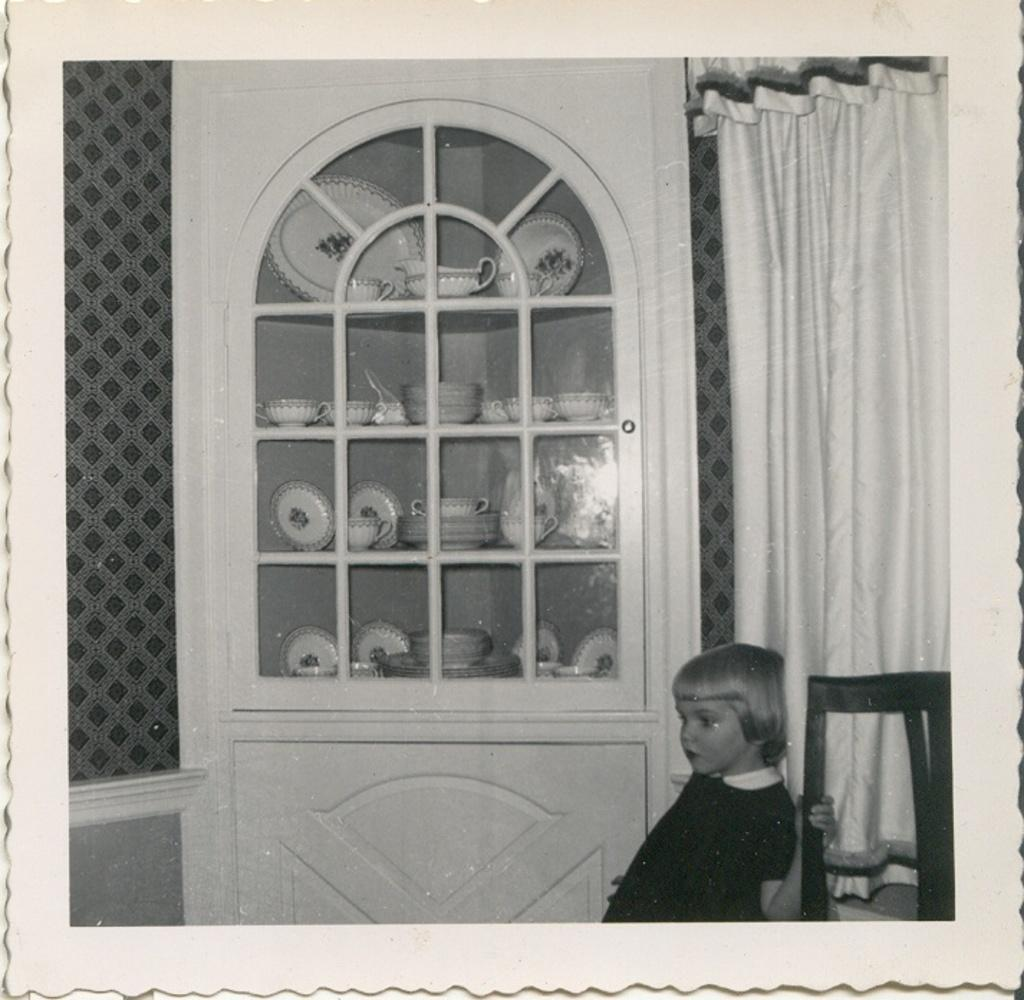What is the color scheme of the image? The image is black and white. What can be seen beside the chair in the image? There is a baby standing beside a chair. What is behind the baby in the image? The baby is in front of a wall with a curtain. What is the main object in the middle of the image? There is a cupboard in the middle of the image. What items can be found inside the cupboard? The cupboard contains cups, bowls, and saucers. How many brass instruments are visible in the image? There are no brass instruments present in the image. What type of arch can be seen in the background of the image? There is no arch visible in the image; it is a black and white image with a baby, chair, wall, curtain, and cupboard. 